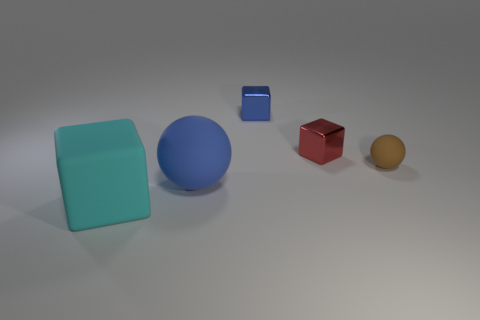How many cyan rubber blocks are there?
Offer a very short reply. 1. How many large brown spheres are made of the same material as the small red cube?
Ensure brevity in your answer.  0. Are there an equal number of matte balls that are left of the tiny blue block and tiny red metallic blocks?
Provide a short and direct response. Yes. What material is the thing that is the same color as the big ball?
Ensure brevity in your answer.  Metal. Is the size of the brown ball the same as the sphere that is left of the tiny blue object?
Ensure brevity in your answer.  No. How many other objects are the same size as the blue cube?
Ensure brevity in your answer.  2. What number of other things are there of the same color as the large ball?
Keep it short and to the point. 1. Is there anything else that has the same size as the blue rubber thing?
Offer a very short reply. Yes. How many other objects are there of the same shape as the big cyan object?
Offer a very short reply. 2. Do the blue matte sphere and the matte cube have the same size?
Offer a very short reply. Yes. 